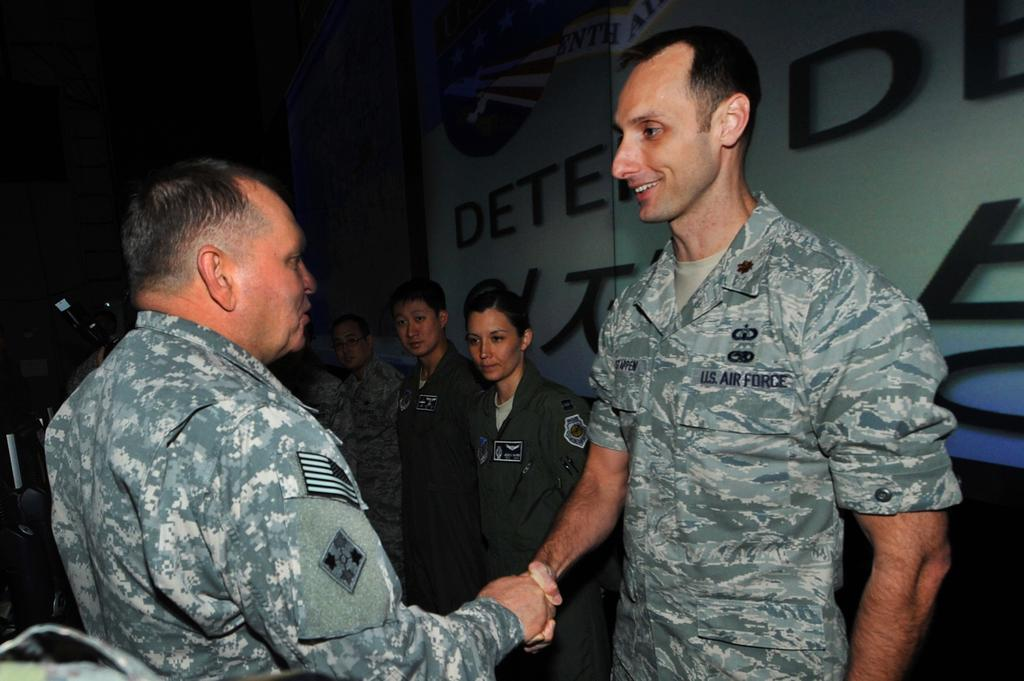How many people are in the image? There are people in the image. What are two of the people doing in the image? Two persons are shaking hands in the image. What can be seen on the wall in the image? There is text on a wall in the image. What is the color of the background in the image? The background of the image is dark. What type of soup is being served in the image? There is no soup present in the image. What scientific theory is being discussed by the people in the image? There is no indication of a scientific discussion or theory in the image. 